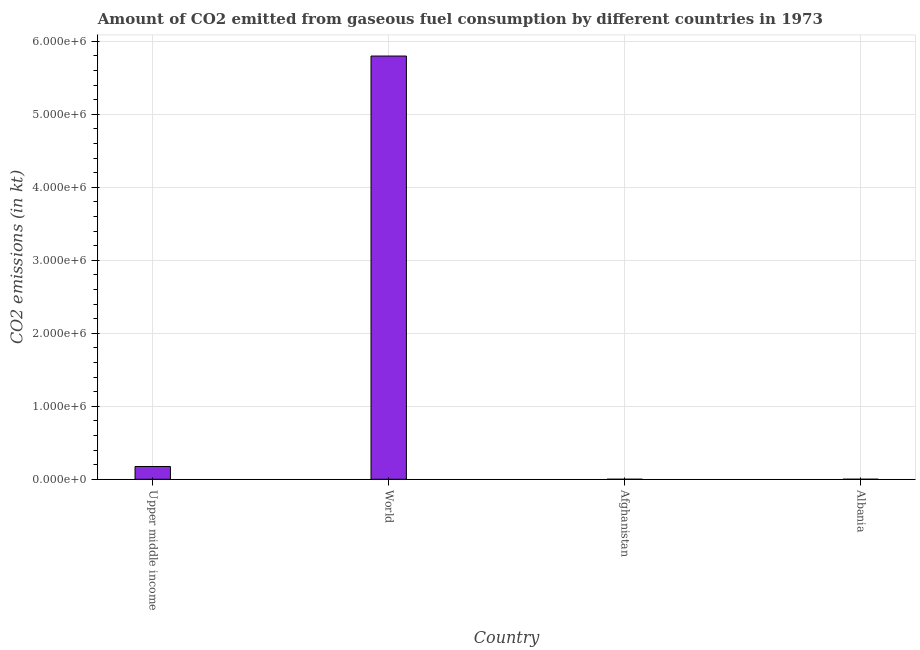Does the graph contain grids?
Provide a short and direct response. Yes. What is the title of the graph?
Offer a terse response. Amount of CO2 emitted from gaseous fuel consumption by different countries in 1973. What is the label or title of the Y-axis?
Make the answer very short. CO2 emissions (in kt). What is the co2 emissions from gaseous fuel consumption in Upper middle income?
Provide a short and direct response. 1.75e+05. Across all countries, what is the maximum co2 emissions from gaseous fuel consumption?
Keep it short and to the point. 5.80e+06. Across all countries, what is the minimum co2 emissions from gaseous fuel consumption?
Ensure brevity in your answer.  333.7. In which country was the co2 emissions from gaseous fuel consumption maximum?
Offer a very short reply. World. In which country was the co2 emissions from gaseous fuel consumption minimum?
Make the answer very short. Afghanistan. What is the sum of the co2 emissions from gaseous fuel consumption?
Offer a terse response. 5.97e+06. What is the difference between the co2 emissions from gaseous fuel consumption in Albania and World?
Provide a succinct answer. -5.80e+06. What is the average co2 emissions from gaseous fuel consumption per country?
Keep it short and to the point. 1.49e+06. What is the median co2 emissions from gaseous fuel consumption?
Keep it short and to the point. 8.77e+04. In how many countries, is the co2 emissions from gaseous fuel consumption greater than 1600000 kt?
Your response must be concise. 1. What is the ratio of the co2 emissions from gaseous fuel consumption in Afghanistan to that in Albania?
Your response must be concise. 0.91. What is the difference between the highest and the second highest co2 emissions from gaseous fuel consumption?
Your answer should be very brief. 5.62e+06. Is the sum of the co2 emissions from gaseous fuel consumption in Afghanistan and Albania greater than the maximum co2 emissions from gaseous fuel consumption across all countries?
Provide a short and direct response. No. What is the difference between the highest and the lowest co2 emissions from gaseous fuel consumption?
Your answer should be compact. 5.80e+06. In how many countries, is the co2 emissions from gaseous fuel consumption greater than the average co2 emissions from gaseous fuel consumption taken over all countries?
Give a very brief answer. 1. Are all the bars in the graph horizontal?
Your answer should be very brief. No. How many countries are there in the graph?
Your answer should be compact. 4. What is the difference between two consecutive major ticks on the Y-axis?
Provide a short and direct response. 1.00e+06. Are the values on the major ticks of Y-axis written in scientific E-notation?
Give a very brief answer. Yes. What is the CO2 emissions (in kt) in Upper middle income?
Your response must be concise. 1.75e+05. What is the CO2 emissions (in kt) of World?
Keep it short and to the point. 5.80e+06. What is the CO2 emissions (in kt) in Afghanistan?
Give a very brief answer. 333.7. What is the CO2 emissions (in kt) in Albania?
Offer a terse response. 366.7. What is the difference between the CO2 emissions (in kt) in Upper middle income and World?
Give a very brief answer. -5.62e+06. What is the difference between the CO2 emissions (in kt) in Upper middle income and Afghanistan?
Make the answer very short. 1.75e+05. What is the difference between the CO2 emissions (in kt) in Upper middle income and Albania?
Your response must be concise. 1.75e+05. What is the difference between the CO2 emissions (in kt) in World and Afghanistan?
Your answer should be very brief. 5.80e+06. What is the difference between the CO2 emissions (in kt) in World and Albania?
Make the answer very short. 5.80e+06. What is the difference between the CO2 emissions (in kt) in Afghanistan and Albania?
Ensure brevity in your answer.  -33. What is the ratio of the CO2 emissions (in kt) in Upper middle income to that in Afghanistan?
Keep it short and to the point. 524.58. What is the ratio of the CO2 emissions (in kt) in Upper middle income to that in Albania?
Offer a very short reply. 477.36. What is the ratio of the CO2 emissions (in kt) in World to that in Afghanistan?
Give a very brief answer. 1.74e+04. What is the ratio of the CO2 emissions (in kt) in World to that in Albania?
Offer a terse response. 1.58e+04. What is the ratio of the CO2 emissions (in kt) in Afghanistan to that in Albania?
Give a very brief answer. 0.91. 